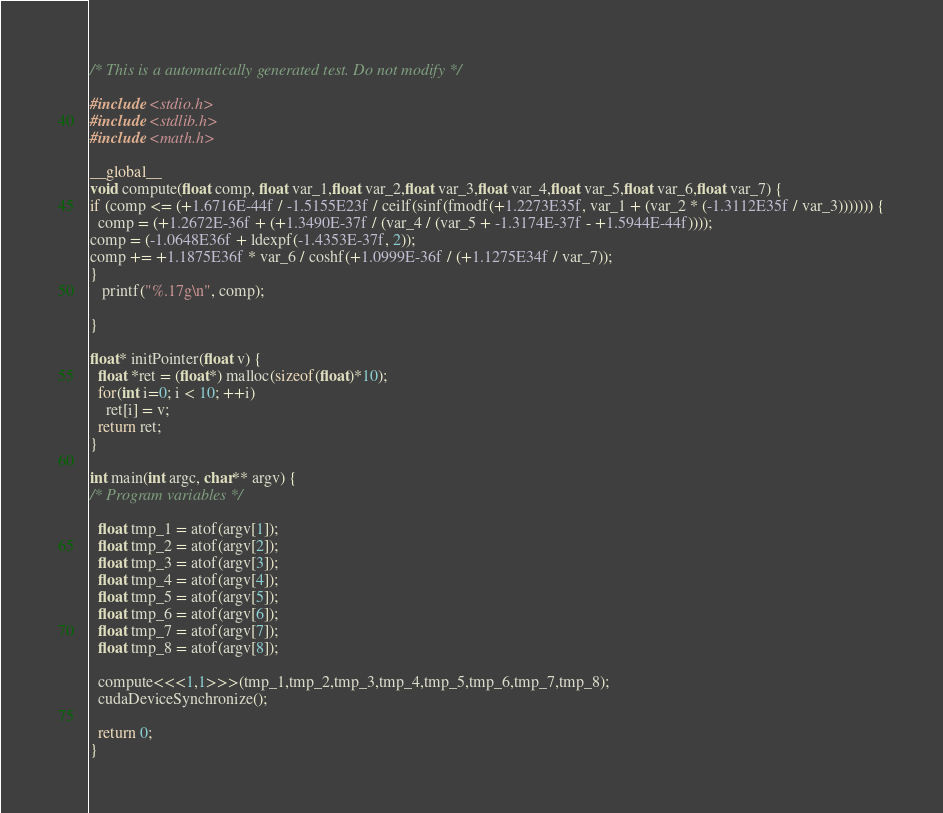<code> <loc_0><loc_0><loc_500><loc_500><_Cuda_>
/* This is a automatically generated test. Do not modify */

#include <stdio.h>
#include <stdlib.h>
#include <math.h>

__global__
void compute(float comp, float var_1,float var_2,float var_3,float var_4,float var_5,float var_6,float var_7) {
if (comp <= (+1.6716E-44f / -1.5155E23f / ceilf(sinf(fmodf(+1.2273E35f, var_1 + (var_2 * (-1.3112E35f / var_3))))))) {
  comp = (+1.2672E-36f + (+1.3490E-37f / (var_4 / (var_5 + -1.3174E-37f - +1.5944E-44f))));
comp = (-1.0648E36f + ldexpf(-1.4353E-37f, 2));
comp += +1.1875E36f * var_6 / coshf(+1.0999E-36f / (+1.1275E34f / var_7));
}
   printf("%.17g\n", comp);

}

float* initPointer(float v) {
  float *ret = (float*) malloc(sizeof(float)*10);
  for(int i=0; i < 10; ++i)
    ret[i] = v;
  return ret;
}

int main(int argc, char** argv) {
/* Program variables */

  float tmp_1 = atof(argv[1]);
  float tmp_2 = atof(argv[2]);
  float tmp_3 = atof(argv[3]);
  float tmp_4 = atof(argv[4]);
  float tmp_5 = atof(argv[5]);
  float tmp_6 = atof(argv[6]);
  float tmp_7 = atof(argv[7]);
  float tmp_8 = atof(argv[8]);

  compute<<<1,1>>>(tmp_1,tmp_2,tmp_3,tmp_4,tmp_5,tmp_6,tmp_7,tmp_8);
  cudaDeviceSynchronize();

  return 0;
}
</code> 